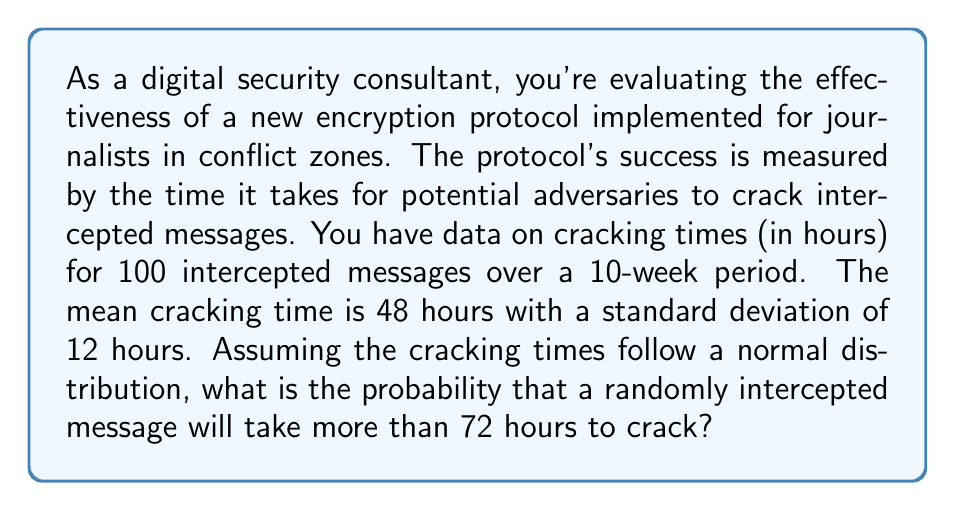Provide a solution to this math problem. To solve this problem, we need to use the properties of the normal distribution and the concept of z-scores.

Given:
- Mean cracking time (μ) = 48 hours
- Standard deviation (σ) = 12 hours
- We want to find P(X > 72), where X is the cracking time

Steps:
1. Calculate the z-score for 72 hours:
   $$z = \frac{x - \mu}{\sigma} = \frac{72 - 48}{12} = 2$$

2. The probability we're looking for is the area under the normal curve to the right of z = 2.

3. Using the standard normal distribution table or a calculator, we need to find:
   $$P(Z > 2) = 1 - P(Z \leq 2)$$

4. From the standard normal table, we find that:
   $$P(Z \leq 2) \approx 0.9772$$

5. Therefore:
   $$P(Z > 2) = 1 - 0.9772 = 0.0228$$

This means there's approximately a 2.28% chance that a randomly intercepted message will take more than 72 hours to crack.

This analysis helps evaluate the effectiveness of the security measure by quantifying the likelihood of messages remaining secure for an extended period, which is crucial for protecting journalists' communications in conflict zones.
Answer: The probability that a randomly intercepted message will take more than 72 hours to crack is approximately 0.0228 or 2.28%. 